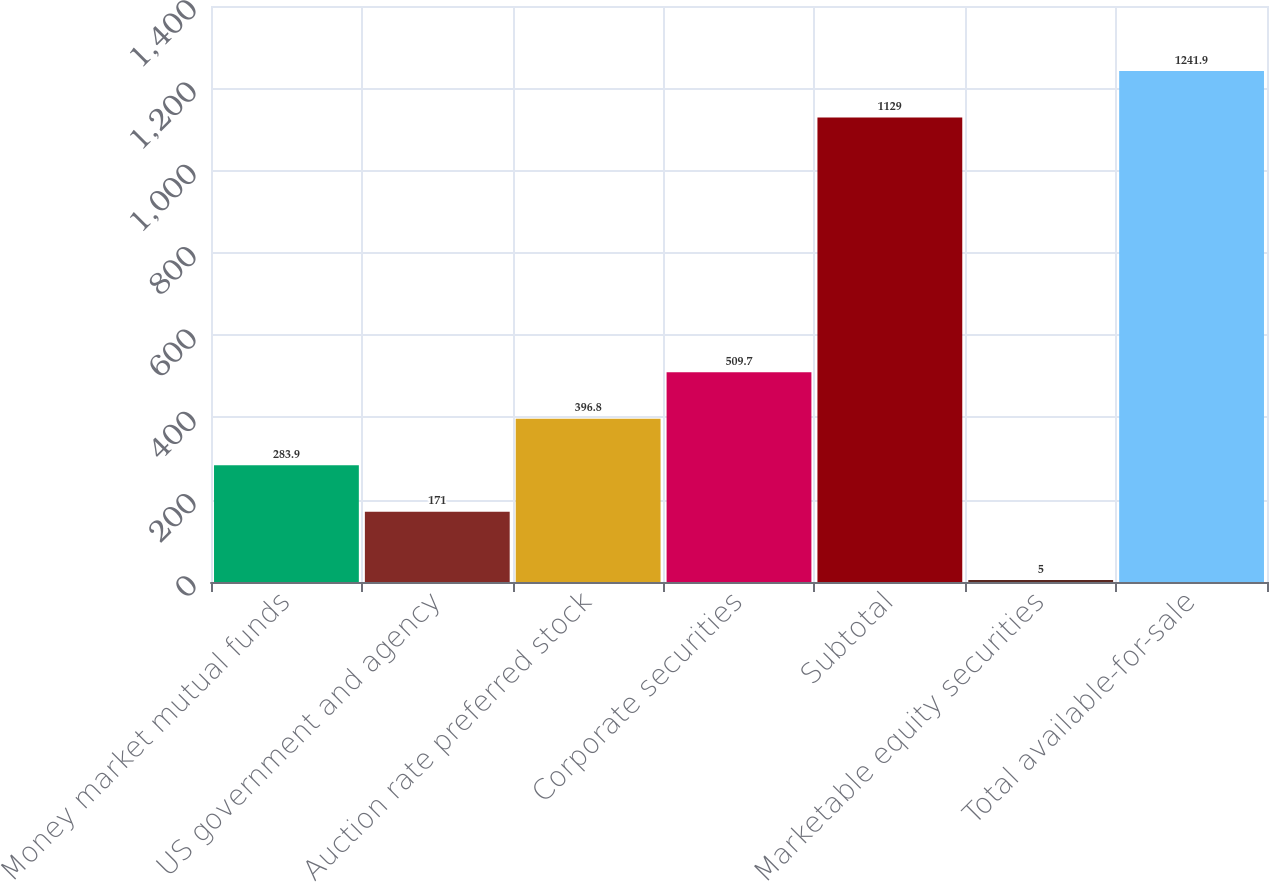Convert chart to OTSL. <chart><loc_0><loc_0><loc_500><loc_500><bar_chart><fcel>Money market mutual funds<fcel>US government and agency<fcel>Auction rate preferred stock<fcel>Corporate securities<fcel>Subtotal<fcel>Marketable equity securities<fcel>Total available-for-sale<nl><fcel>283.9<fcel>171<fcel>396.8<fcel>509.7<fcel>1129<fcel>5<fcel>1241.9<nl></chart> 